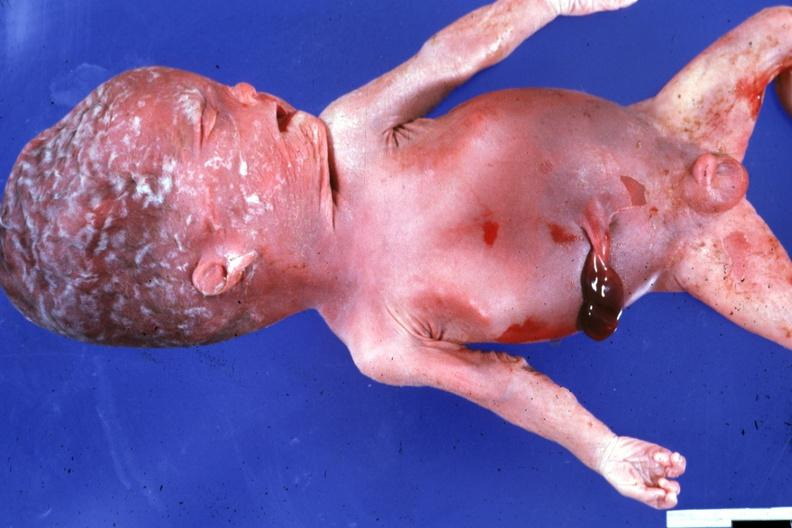does acute peritonitis show typical not advanced macerated stillborn?
Answer the question using a single word or phrase. No 